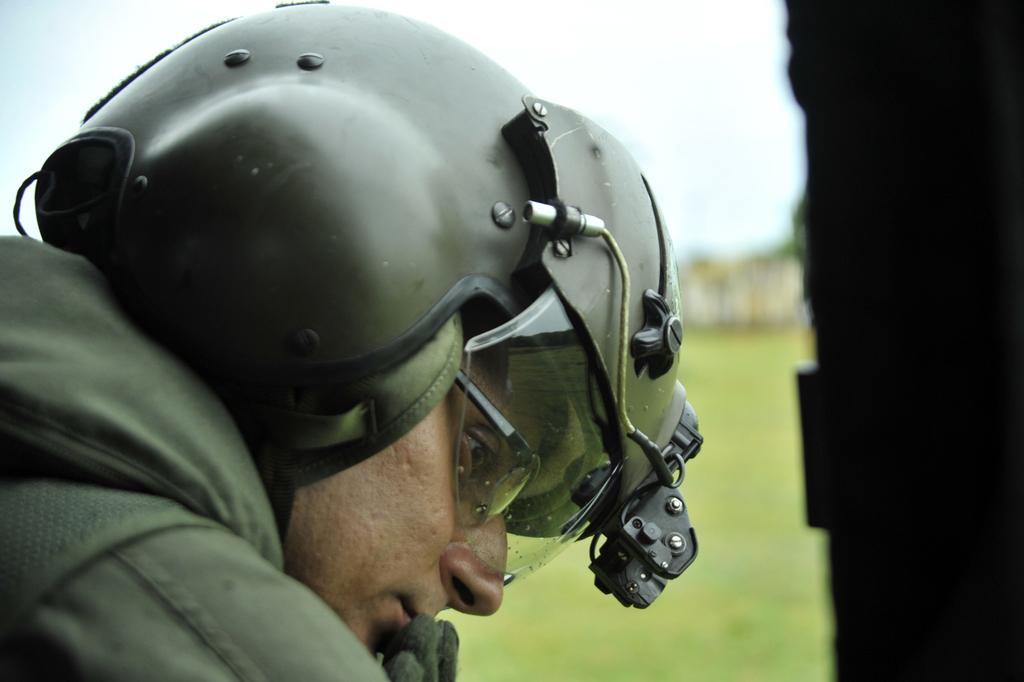Who is present in the image? There is a man in the image. What is the man wearing on his head? The man is wearing a helmet. Can you describe the background of the image? The background of the image is blurred. How many geese are visible in the image? There are no geese present in the image. What type of zebra can be seen in the background of the image? There is no zebra present in the image, and the background is blurred. 